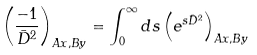<formula> <loc_0><loc_0><loc_500><loc_500>\left ( \frac { - 1 } { \bar { D } ^ { 2 } } \right ) _ { A x , B y } = \int _ { 0 } ^ { \infty } d s \left ( e ^ { s \bar { D } ^ { 2 } } \right ) _ { A x , B y }</formula> 